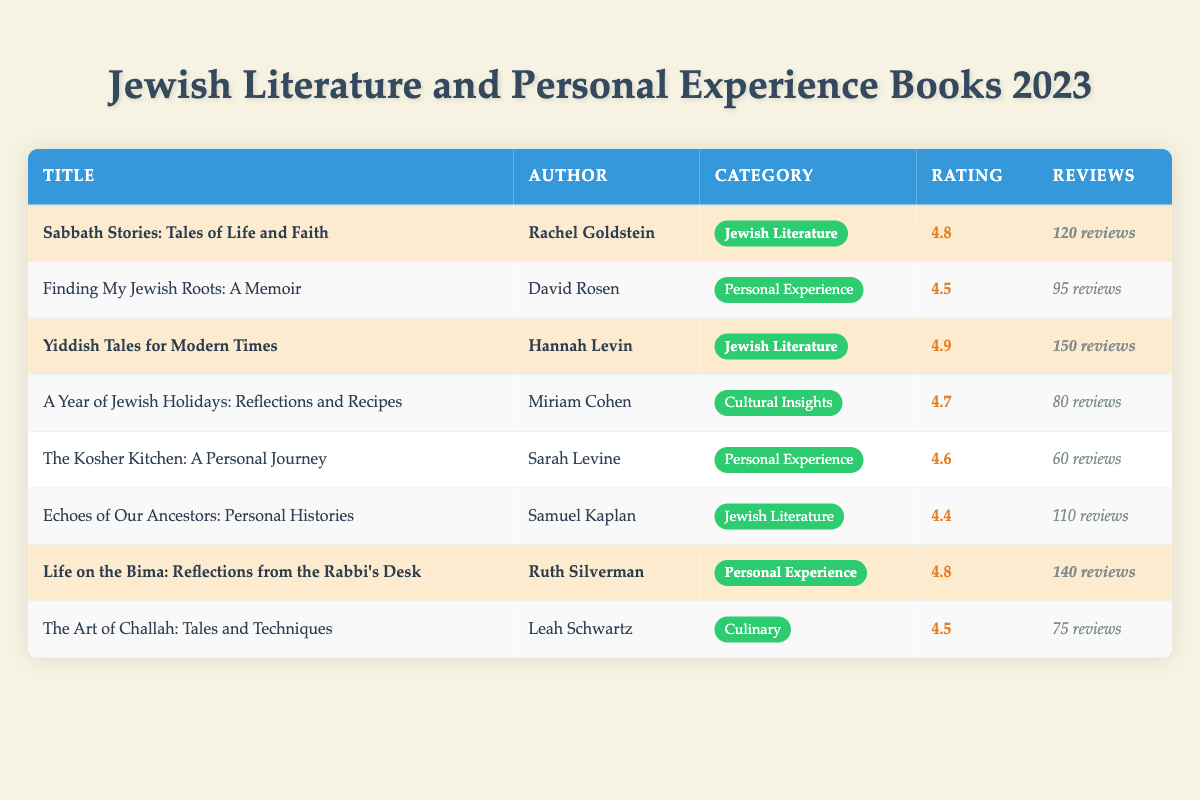What is the highest feedback rating among the highlighted books? The table lists three highlighted books: "Sabbath Stories: Tales of Life and Faith" with a rating of 4.8, "Yiddish Tales for Modern Times" with a rating of 4.9, and "Life on the Bima: Reflections from the Rabbi's Desk" with a rating of 4.8. Among these, 4.9 is the highest.
Answer: 4.9 Who is the author of the book with the highest number of reviews? The book with the highest number of reviews is "Yiddish Tales for Modern Times" with 150 reviews. Its author is Hannah Levin.
Answer: Hannah Levin How many reviews do the three highlighted books have in total? The highlighted books are "Sabbath Stories: Tales of Life and Faith" (120 reviews), "Yiddish Tales for Modern Times" (150 reviews), and "Life on the Bima: Reflections from the Rabbi's Desk" (140 reviews). Summing these gives 120 + 150 + 140 = 410 reviews.
Answer: 410 Is there a book in the Personal Experience category that has a feedback rating of 4.8 or higher? Checking the Personal Experience books, "Finding My Jewish Roots: A Memoir" has a rating of 4.5, "The Kosher Kitchen: A Personal Journey" has a rating of 4.6, and "Life on the Bima: Reflections from the Rabbi's Desk" has a rating of 4.8. Thus, there is at least one book that meets the criteria.
Answer: Yes What is the average feedback rating of the books listed in the Jewish Literature category? The Jewish Literature books are "Sabbath Stories: Tales of Life and Faith" (4.8), "Yiddish Tales for Modern Times" (4.9), and "Echoes of Our Ancestors: Personal Histories" (4.4). Adding these gives 4.8 + 4.9 + 4.4 = 14.1. Dividing by the total number of books (3) gives an average of 14.1 / 3 = 4.7.
Answer: 4.7 Which author appears to have written two books in the table, if any? Each author appears to have written only one book listed in the table; thus, there are no authors with two books.
Answer: No What is the difference in the number of reviews between the book with the most and the least reviews? The book with the most reviews is "Yiddish Tales for Modern Times" with 150 reviews and the book with the least reviews is "The Art of Challah: Tales and Techniques" with 75 reviews. The difference is 150 - 75 = 75.
Answer: 75 How many Jewish literature books are highlighted? Out of the three Jewish Literature books, "Sabbath Stories: Tales of Life and Faith" and "Yiddish Tales for Modern Times" are highlighted (two total).
Answer: 2 What percentage of the reviews for "Life on the Bima: Reflections from the Rabbi's Desk" compared to the total reviews of highlighted books? "Life on the Bima: Reflections from the Rabbi's Desk" has 140 reviews, while the highlighted books have a total of 410 reviews. The percentage is (140 / 410) * 100 ≈ 34.15%.
Answer: 34.15% 